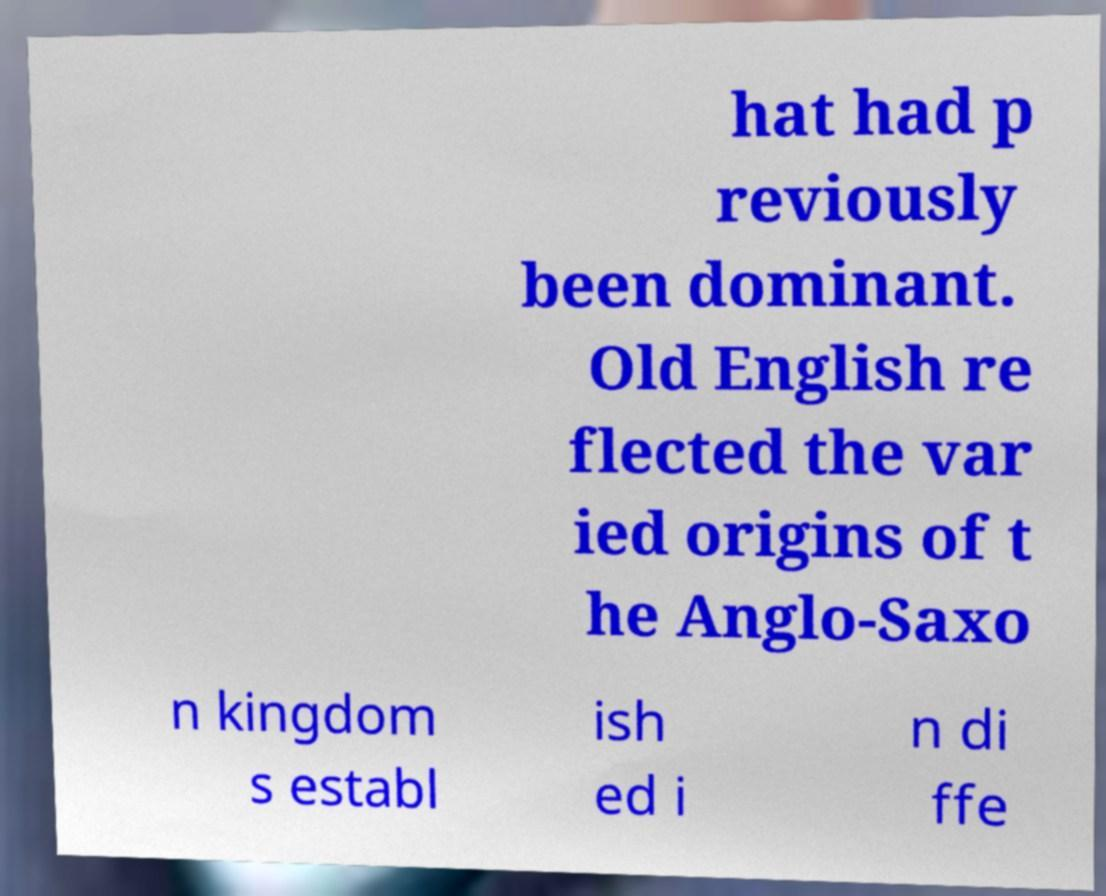I need the written content from this picture converted into text. Can you do that? hat had p reviously been dominant. Old English re flected the var ied origins of t he Anglo-Saxo n kingdom s establ ish ed i n di ffe 